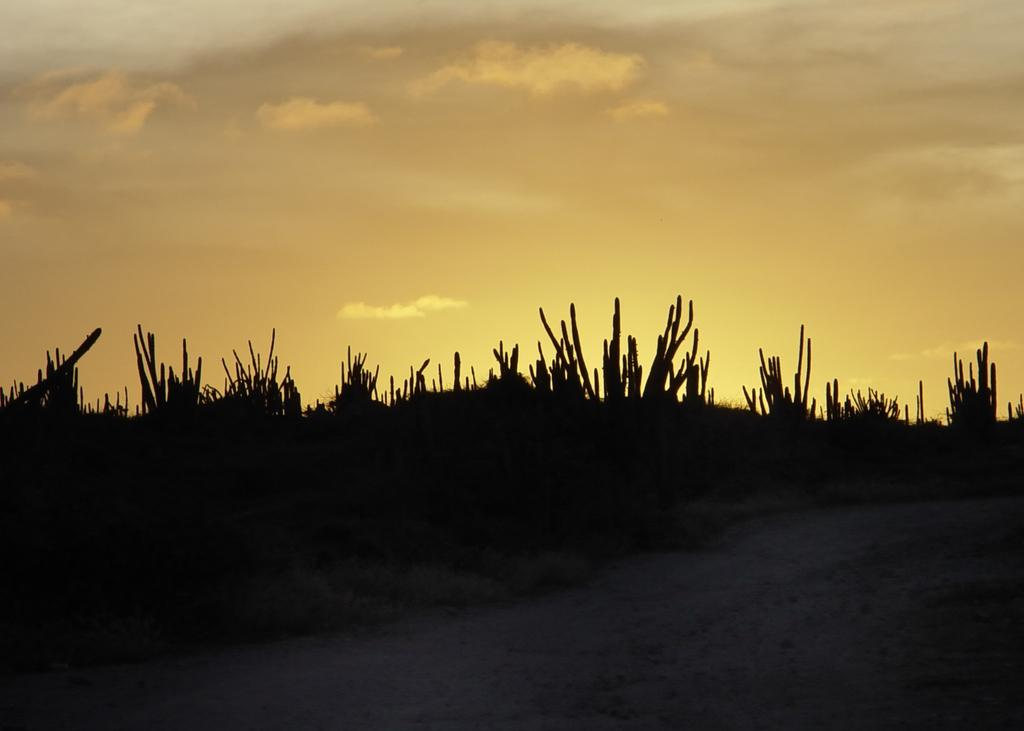What is located in the center of the image? There are plants in the center of the image. What can be seen at the bottom of the image? There is a walkway at the bottom of the image. What is visible at the top of the image? The sky is visible at the top of the image. Where are the ducks located in the image? There are no ducks present in the image. Is there a volcano visible in the image? No, there is no volcano present in the image. Can you see a drum being played in the image? There is no drum or any musical instrument being played in the image. 